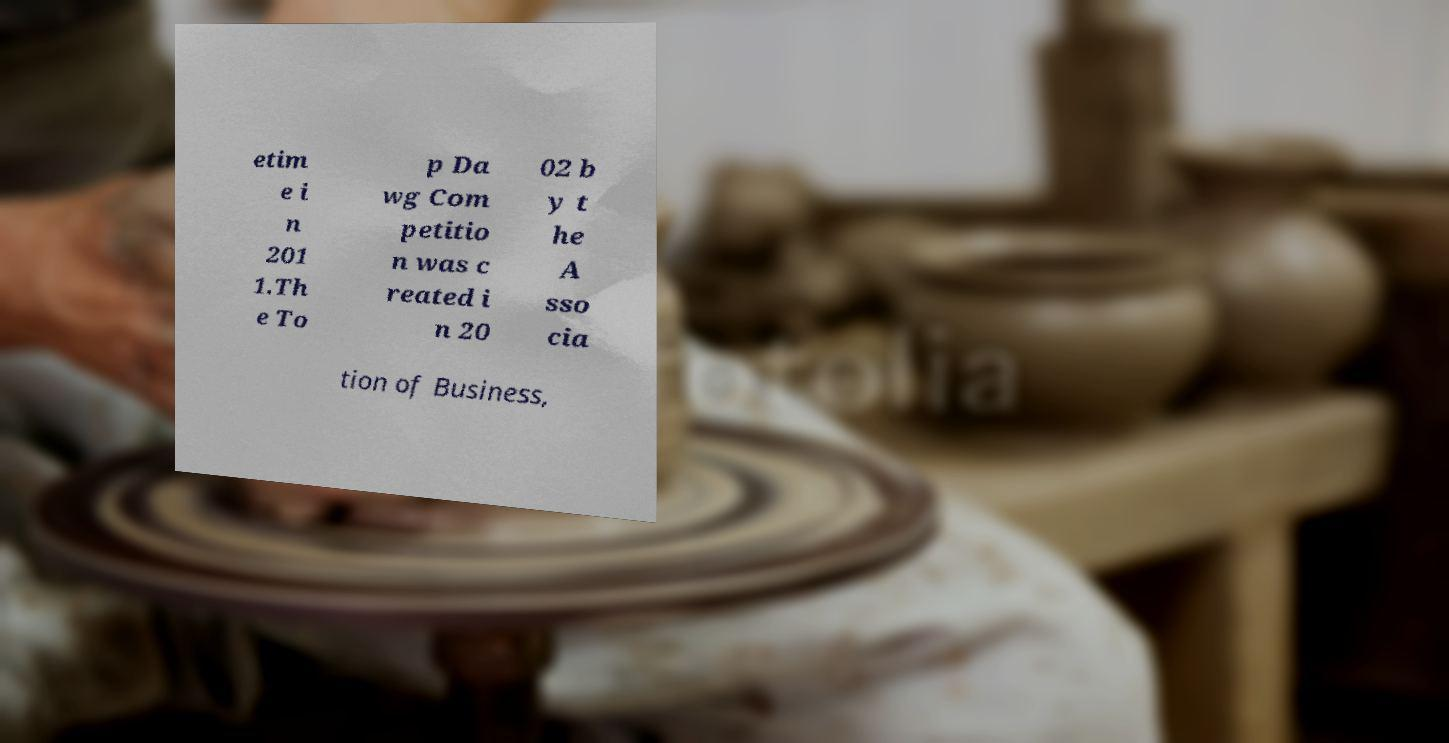Can you accurately transcribe the text from the provided image for me? etim e i n 201 1.Th e To p Da wg Com petitio n was c reated i n 20 02 b y t he A sso cia tion of Business, 